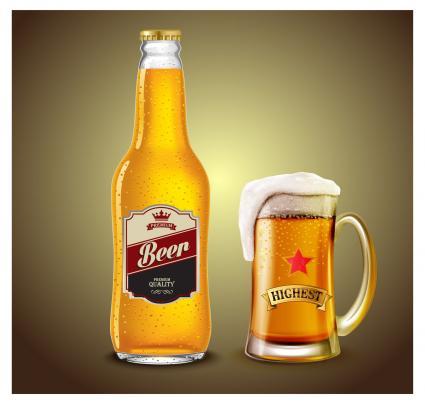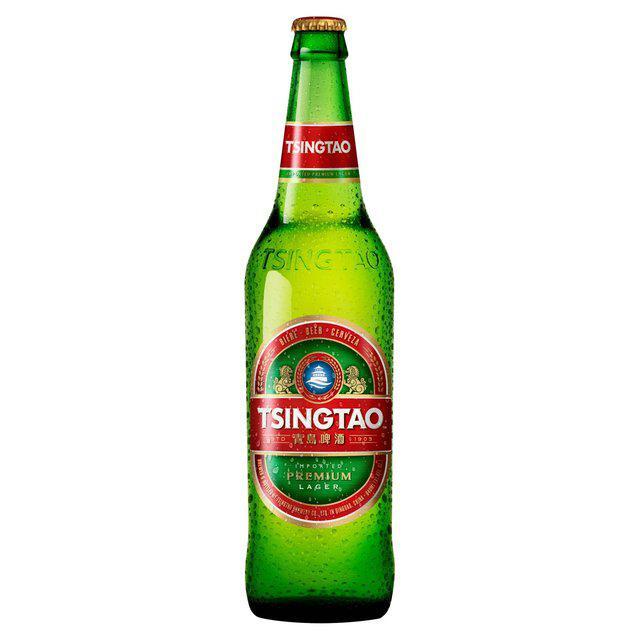The first image is the image on the left, the second image is the image on the right. Given the left and right images, does the statement "One image is a single dark brown glass bottle." hold true? Answer yes or no. No. 